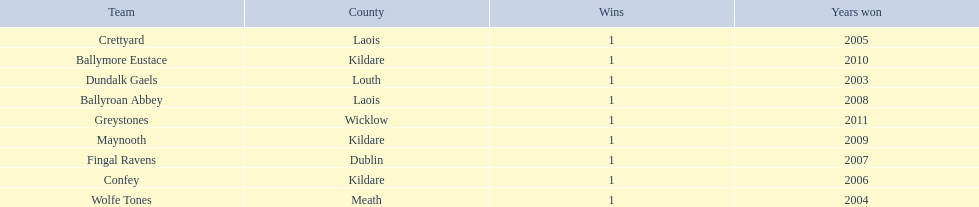What county is ballymore eustace from? Kildare. Besides convey, which other team is from the same county? Maynooth. 